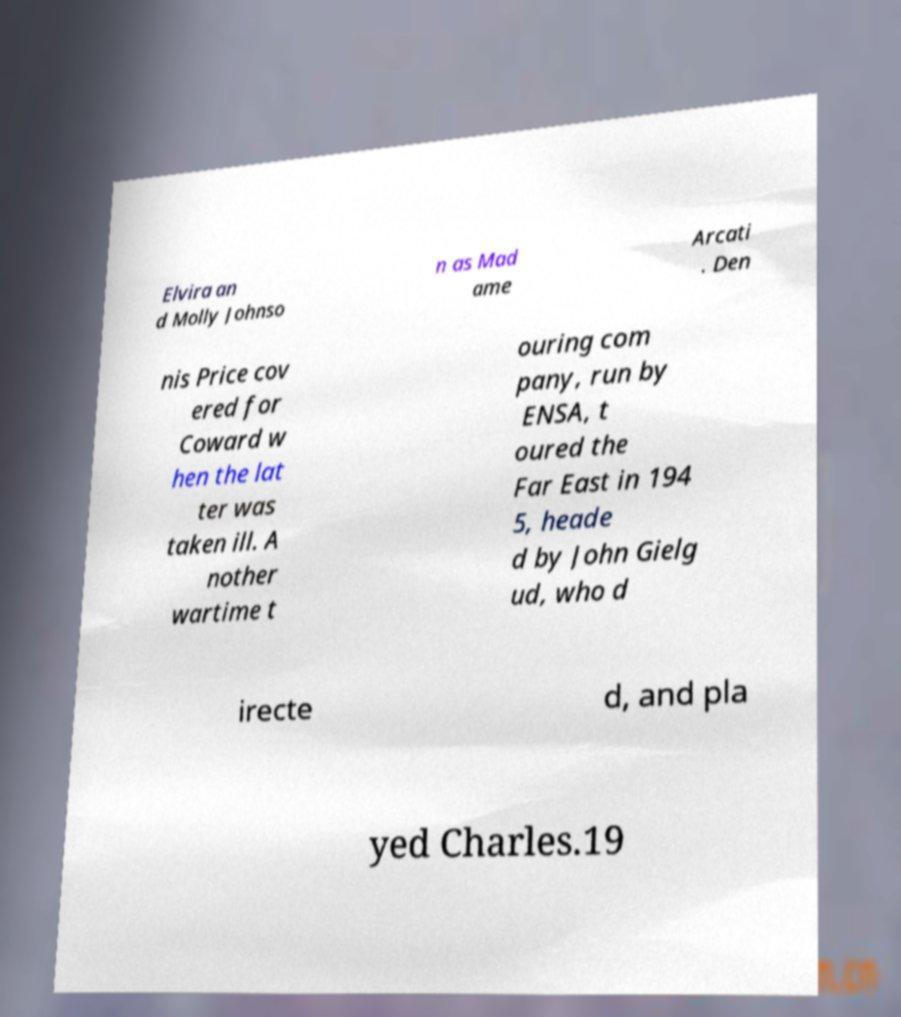Can you accurately transcribe the text from the provided image for me? Elvira an d Molly Johnso n as Mad ame Arcati . Den nis Price cov ered for Coward w hen the lat ter was taken ill. A nother wartime t ouring com pany, run by ENSA, t oured the Far East in 194 5, heade d by John Gielg ud, who d irecte d, and pla yed Charles.19 